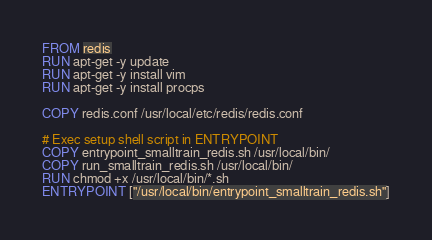<code> <loc_0><loc_0><loc_500><loc_500><_Dockerfile_>FROM redis
RUN apt-get -y update
RUN apt-get -y install vim
RUN apt-get -y install procps

COPY redis.conf /usr/local/etc/redis/redis.conf

# Exec setup shell script in ENTRYPOINT
COPY entrypoint_smalltrain_redis.sh /usr/local/bin/
COPY run_smalltrain_redis.sh /usr/local/bin/
RUN chmod +x /usr/local/bin/*.sh
ENTRYPOINT ["/usr/local/bin/entrypoint_smalltrain_redis.sh"]

</code> 